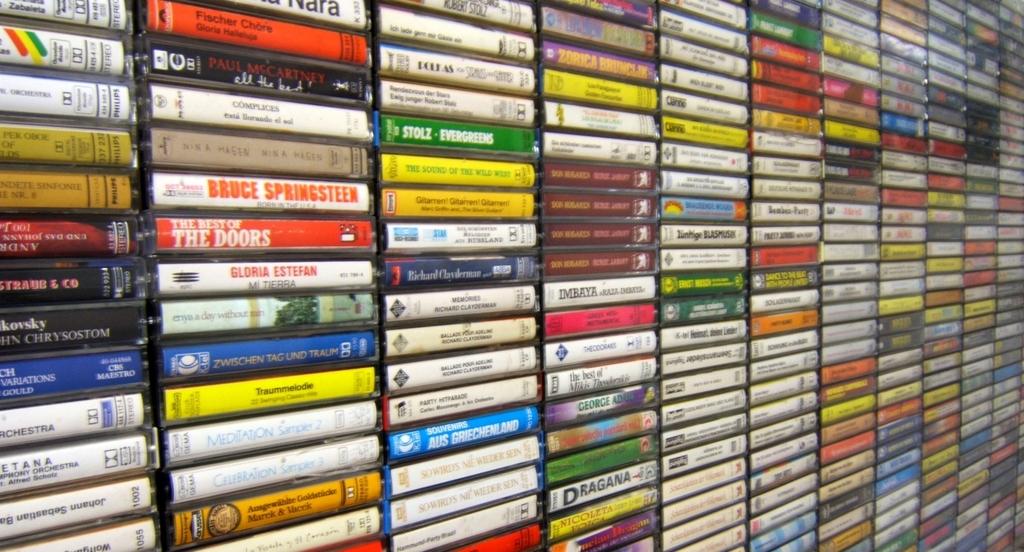What the doors album is part of this collection?
Make the answer very short. The best of the doors. What album is above the doors?
Give a very brief answer. Bruce springsteen. 